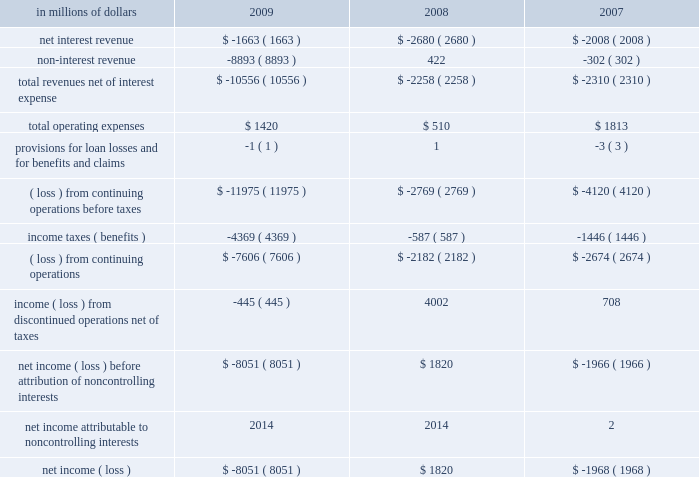Corporate/other corporate/other includes global staff functions ( includes finance , risk , human resources , legal and compliance ) and other corporate expense , global operations and technology ( o&t ) , residual corporate treasury and corporate items .
At december 31 , 2009 , this segment had approximately $ 230 billion of assets , consisting primarily of the company 2019s liquidity portfolio , including $ 110 billion of cash and cash equivalents. .
2009 vs .
2008 revenues , net of interest expense declined , primarily due to the pretax loss on debt extinguishment related to the repayment of the $ 20 billion of tarp trust preferred securities and the pretax loss in connection with the exit from the loss-sharing agreement with the u.s .
Government .
Revenues also declined , due to the absence of the 2008 sale of citigroup global services limited recorded in o&t .
This was partially offset by a pretax gain related to the exchange offers , revenues and higher intersegment eliminations .
Operating expenses increased , primarily due to intersegment eliminations and increases in compensation , partially offset by lower repositioning reserves .
2008 vs .
2007 revenues , net of interest expense increased primarily due to the gain in 2007 on the sale of certain corporate-owned assets and higher intersegment eliminations , partially offset by improved treasury hedging activities .
Operating expenses declined , primarily due to lower restructuring charges in 2008 as well as reductions in incentive compensation and benefits expense. .
What was the percentage change in total operating expenses between 2008 and 2009? 
Computations: ((1420 - 510) / 510)
Answer: 1.78431. Corporate/other corporate/other includes global staff functions ( includes finance , risk , human resources , legal and compliance ) and other corporate expense , global operations and technology ( o&t ) , residual corporate treasury and corporate items .
At december 31 , 2009 , this segment had approximately $ 230 billion of assets , consisting primarily of the company 2019s liquidity portfolio , including $ 110 billion of cash and cash equivalents. .
2009 vs .
2008 revenues , net of interest expense declined , primarily due to the pretax loss on debt extinguishment related to the repayment of the $ 20 billion of tarp trust preferred securities and the pretax loss in connection with the exit from the loss-sharing agreement with the u.s .
Government .
Revenues also declined , due to the absence of the 2008 sale of citigroup global services limited recorded in o&t .
This was partially offset by a pretax gain related to the exchange offers , revenues and higher intersegment eliminations .
Operating expenses increased , primarily due to intersegment eliminations and increases in compensation , partially offset by lower repositioning reserves .
2008 vs .
2007 revenues , net of interest expense increased primarily due to the gain in 2007 on the sale of certain corporate-owned assets and higher intersegment eliminations , partially offset by improved treasury hedging activities .
Operating expenses declined , primarily due to lower restructuring charges in 2008 as well as reductions in incentive compensation and benefits expense. .
What was the percentage change in total operating expenses between 2007 and 2008? 
Computations: ((510 - 1813) / 1813)
Answer: -0.7187. 